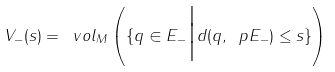Convert formula to latex. <formula><loc_0><loc_0><loc_500><loc_500>V _ { - } ( s ) = \ v o l _ { M } \left ( \{ q \in E _ { - } \Big | d ( q , \ p E _ { - } ) \leq s \} \right )</formula> 